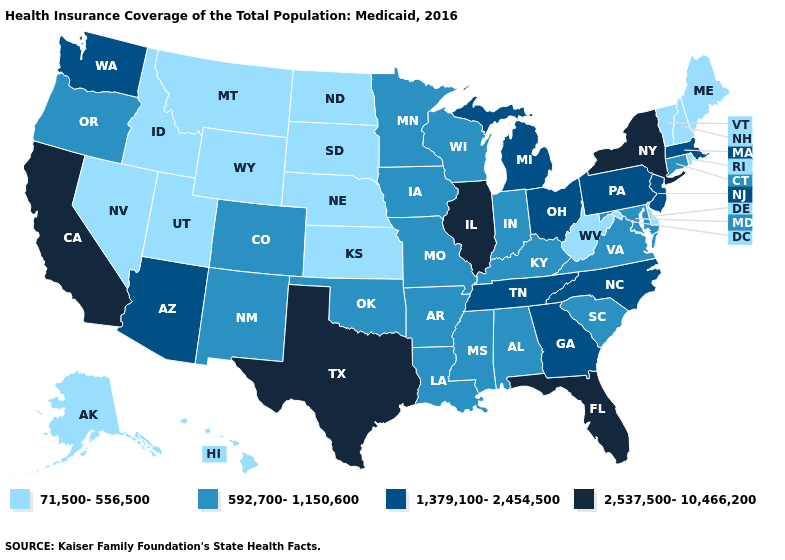Among the states that border Iowa , does Illinois have the highest value?
Be succinct. Yes. What is the value of North Dakota?
Keep it brief. 71,500-556,500. Does Wyoming have the lowest value in the West?
Answer briefly. Yes. What is the lowest value in the USA?
Write a very short answer. 71,500-556,500. Does Wisconsin have the highest value in the MidWest?
Answer briefly. No. Name the states that have a value in the range 71,500-556,500?
Give a very brief answer. Alaska, Delaware, Hawaii, Idaho, Kansas, Maine, Montana, Nebraska, Nevada, New Hampshire, North Dakota, Rhode Island, South Dakota, Utah, Vermont, West Virginia, Wyoming. Does the map have missing data?
Short answer required. No. Name the states that have a value in the range 2,537,500-10,466,200?
Answer briefly. California, Florida, Illinois, New York, Texas. How many symbols are there in the legend?
Short answer required. 4. Name the states that have a value in the range 1,379,100-2,454,500?
Give a very brief answer. Arizona, Georgia, Massachusetts, Michigan, New Jersey, North Carolina, Ohio, Pennsylvania, Tennessee, Washington. Does Illinois have the highest value in the MidWest?
Short answer required. Yes. Among the states that border Oregon , does Washington have the lowest value?
Short answer required. No. Does New Jersey have the lowest value in the Northeast?
Keep it brief. No. Among the states that border California , which have the highest value?
Short answer required. Arizona. Name the states that have a value in the range 2,537,500-10,466,200?
Be succinct. California, Florida, Illinois, New York, Texas. 